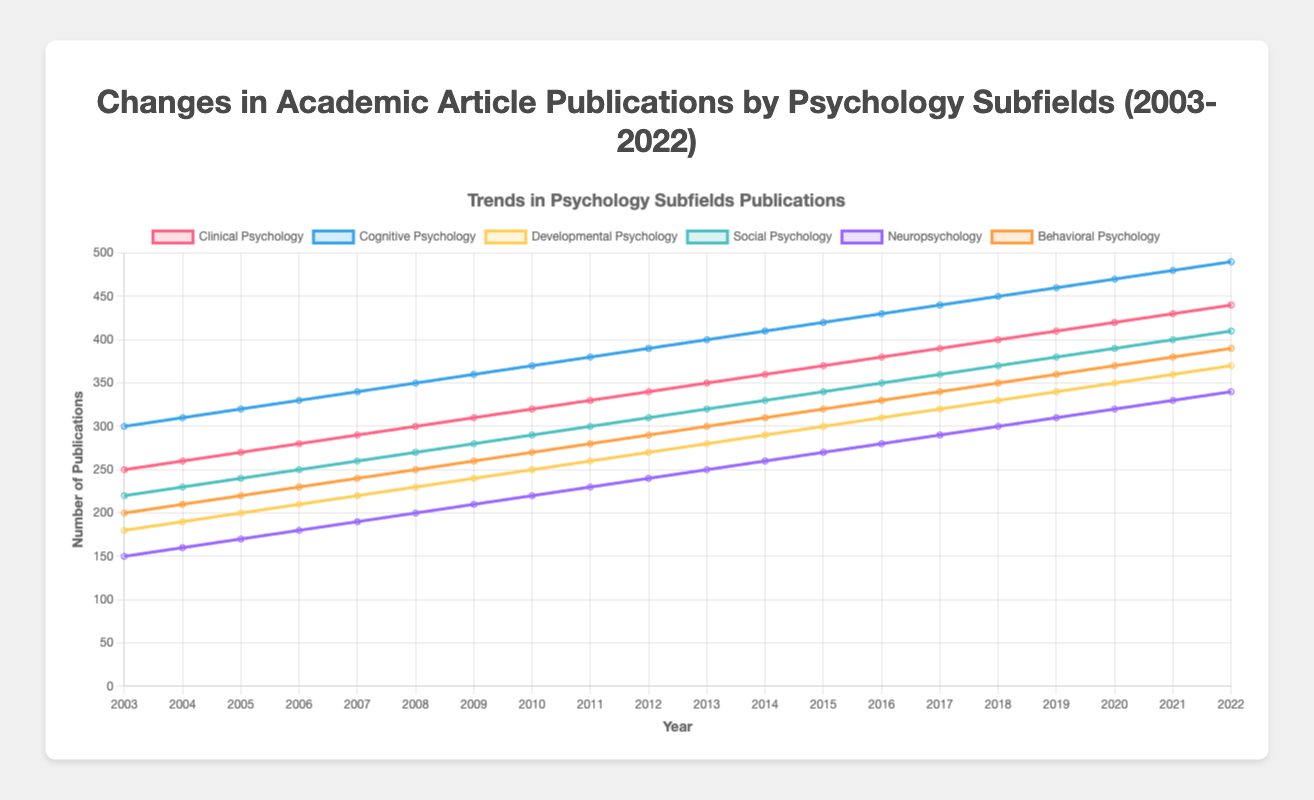What is the general trend of publications in Clinical Psychology from 2003 to 2022? The curve for Clinical Psychology consistently rises from 250 publications in 2003 to 440 publications in 2022. This indicates a steady increase in the number of publications over the years.
Answer: Steady increase Which subfield had the highest number of publications in 2022? In 2022, Cognitive Psychology had the highest number of publications compared to other subfields, with 490 publications.
Answer: Cognitive Psychology What is the difference in the number of publications between Social Psychology and Neuropsychology in 2020? In 2020, Social Psychology had 390 publications, and Neuropsychology had 320 publications. The difference is 390 - 320 = 70 publications.
Answer: 70 publications How did the number of publications in Behavioral Psychology change from 2003 to 2012? In 2003, Behavioral Psychology had 200 publications, and in 2012, it had 290 publications. The change is 290 - 200 = 90. This indicates an increase of 90 publications over this period.
Answer: Increased by 90 publications Which subfield experienced the smallest increase in publications between 2003 and 2022? From 2003 to 2022, Neuropsychology experienced an increase from 150 to 340 publications. The difference is 340 - 150 = 190. Comparing increases in all subfields, Neuropsychology had the smallest increase.
Answer: Neuropsychology What is the sum of publications in Developmental Psychology and Social Psychology in the year 2017? In 2017, Developmental Psychology had 320 publications, and Social Psychology had 360 publications. The sum is 320 + 360 = 680.
Answer: 680 publications Between which two consecutive years did Cognitive Psychology see the largest increase in publications? Observing the yearly increases, the largest jump for Cognitive Psychology is between 2006 (330 publications) and 2007 (340 publications), a difference of 10. However, the largest increase in a single year is from 2021 (480) to 2022 (490), an increase of 10. Considering the whole period, the largest jump is consistent at 10.
Answer: 2021 and 2022 Which subfield shows a consistent upward trend without any drops across all the years? Clinical Psychology, Cognitive Psychology, Developmental Psychology, Social Psychology, Neuropsychology, and Behavioral Psychology all show consistent upward trends without any drops.
Answer: All subfields How many publications in total were there for Cognitive Psychology in 2010 and 2020? In 2010, Cognitive Psychology had 370 publications, and in 2020, it had 470 publications. The total is 370 + 470 = 840.
Answer: 840 publications 